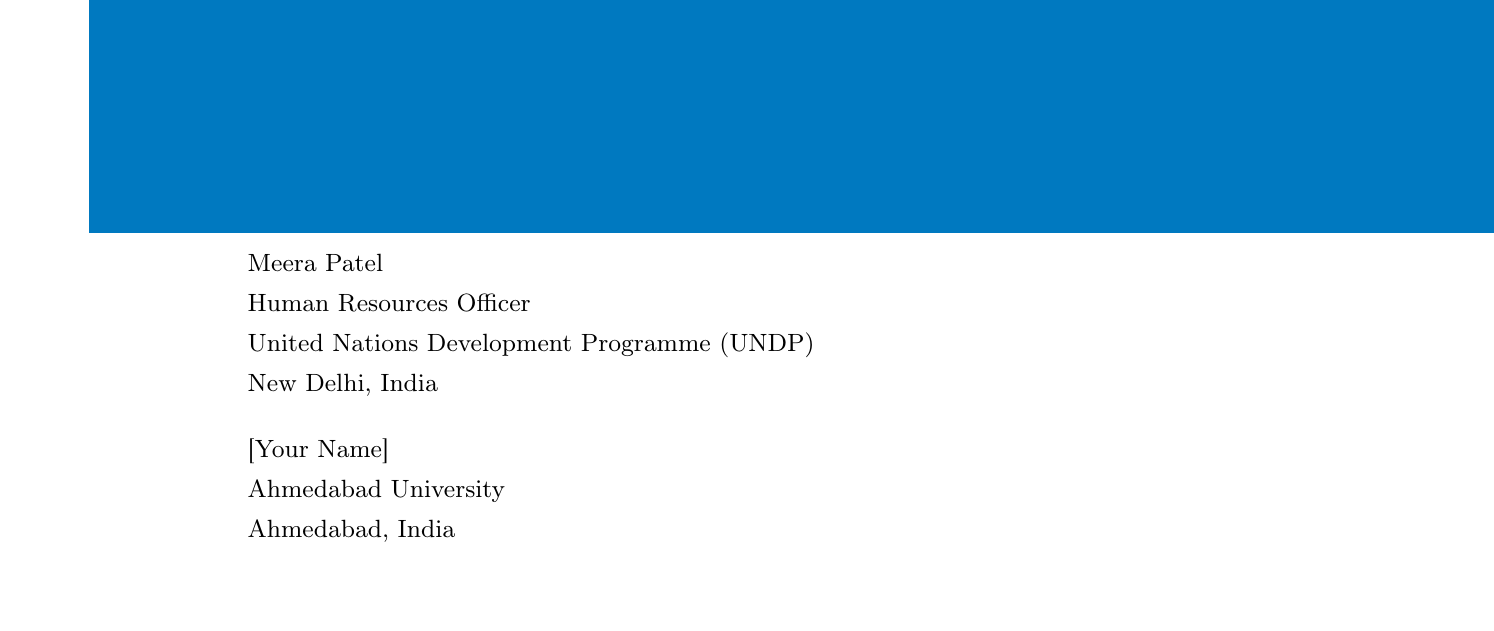what is the duration of the internship? The duration of the internship is mentioned in the document as from June 1 to August 31, 2023.
Answer: 3 months who is the sender of the email? The sender is identified in the document, providing their name and title.
Answer: Meera Patel what is the application submission deadline? The deadline for submitting the required documents is explicitly stated in the document.
Answer: April 15, 2023 how many letters of recommendation are required? The number of letters of recommendation necessary for the application is specified in the required documents section.
Answer: Two what is the eligibility criteria regarding GPA? The document states the minimum GPA requirement for applicants.
Answer: 3.5 who should be contacted for more information? The person to contact for additional details is outlined in the additional information section.
Answer: Ms. Anjali Sharma is the internship paid or unpaid? The financial compensation status for the internship is provided in the additional information section.
Answer: Unpaid what is the expected weekly working hours? The document specifies the number of hours expected to work each week during the internship.
Answer: 40 hours per week what type of degree programs must applicants be enrolled in? The document specifies the level of degree programs acceptable for applicants.
Answer: Bachelor's or master's degree program what is the location of the internship? The location of the internship is mentioned under the internship details in the document.
Answer: New Delhi, India 